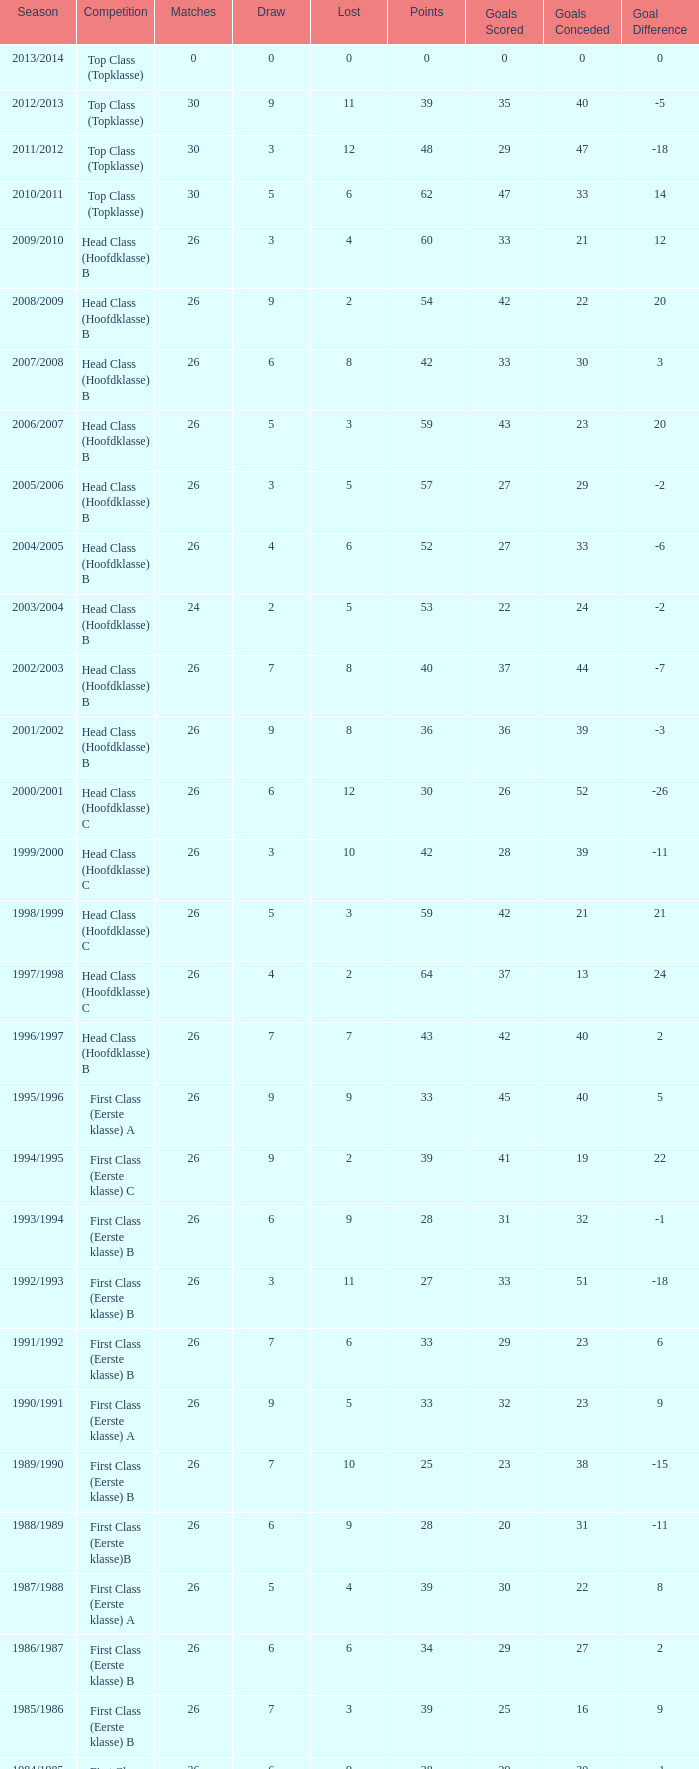Parse the table in full. {'header': ['Season', 'Competition', 'Matches', 'Draw', 'Lost', 'Points', 'Goals Scored', 'Goals Conceded', 'Goal Difference'], 'rows': [['2013/2014', 'Top Class (Topklasse)', '0', '0', '0', '0', '0', '0', '0'], ['2012/2013', 'Top Class (Topklasse)', '30', '9', '11', '39', '35', '40', '-5'], ['2011/2012', 'Top Class (Topklasse)', '30', '3', '12', '48', '29', '47', '-18'], ['2010/2011', 'Top Class (Topklasse)', '30', '5', '6', '62', '47', '33', '14'], ['2009/2010', 'Head Class (Hoofdklasse) B', '26', '3', '4', '60', '33', '21', '12'], ['2008/2009', 'Head Class (Hoofdklasse) B', '26', '9', '2', '54', '42', '22', '20'], ['2007/2008', 'Head Class (Hoofdklasse) B', '26', '6', '8', '42', '33', '30', '3'], ['2006/2007', 'Head Class (Hoofdklasse) B', '26', '5', '3', '59', '43', '23', '20'], ['2005/2006', 'Head Class (Hoofdklasse) B', '26', '3', '5', '57', '27', '29', '-2'], ['2004/2005', 'Head Class (Hoofdklasse) B', '26', '4', '6', '52', '27', '33', '-6'], ['2003/2004', 'Head Class (Hoofdklasse) B', '24', '2', '5', '53', '22', '24', '-2'], ['2002/2003', 'Head Class (Hoofdklasse) B', '26', '7', '8', '40', '37', '44', '-7'], ['2001/2002', 'Head Class (Hoofdklasse) B', '26', '9', '8', '36', '36', '39', '-3'], ['2000/2001', 'Head Class (Hoofdklasse) C', '26', '6', '12', '30', '26', '52', '-26'], ['1999/2000', 'Head Class (Hoofdklasse) C', '26', '3', '10', '42', '28', '39', '-11'], ['1998/1999', 'Head Class (Hoofdklasse) C', '26', '5', '3', '59', '42', '21', '21'], ['1997/1998', 'Head Class (Hoofdklasse) C', '26', '4', '2', '64', '37', '13', '24'], ['1996/1997', 'Head Class (Hoofdklasse) B', '26', '7', '7', '43', '42', '40', '2'], ['1995/1996', 'First Class (Eerste klasse) A', '26', '9', '9', '33', '45', '40', '5'], ['1994/1995', 'First Class (Eerste klasse) C', '26', '9', '2', '39', '41', '19', '22'], ['1993/1994', 'First Class (Eerste klasse) B', '26', '6', '9', '28', '31', '32', '-1'], ['1992/1993', 'First Class (Eerste klasse) B', '26', '3', '11', '27', '33', '51', '-18'], ['1991/1992', 'First Class (Eerste klasse) B', '26', '7', '6', '33', '29', '23', '6'], ['1990/1991', 'First Class (Eerste klasse) A', '26', '9', '5', '33', '32', '23', '9'], ['1989/1990', 'First Class (Eerste klasse) B', '26', '7', '10', '25', '23', '38', '-15'], ['1988/1989', 'First Class (Eerste klasse)B', '26', '6', '9', '28', '20', '31', '-11'], ['1987/1988', 'First Class (Eerste klasse) A', '26', '5', '4', '39', '30', '22', '8'], ['1986/1987', 'First Class (Eerste klasse) B', '26', '6', '6', '34', '29', '27', '2'], ['1985/1986', 'First Class (Eerste klasse) B', '26', '7', '3', '39', '25', '16', '9'], ['1984/1985', 'First Class (Eerste klasse) B', '26', '6', '9', '28', '29', '30', '-1'], ['1983/1984', 'First Class (Eerste klasse) C', '26', '5', '3', '37', '21', '15', '6'], ['1982/1983', 'First Class (Eerste klasse) B', '26', '10', '1', '40', '57', '15', '42'], ['1981/1982', 'First Class (Eerste klasse) B', '26', '8', '3', '38', '43', '28', '15'], ['1980/1981', 'First Class (Eerste klasse) A', '26', '5', '10', '27', '26', '36', '-10'], ['1979/1980', 'First Class (Eerste klasse) B', '26', '6', '9', '28', '24', '37', '-13'], ['1978/1979', 'First Class (Eerste klasse) A', '26', '7', '6', '33', '21', '22', '-1'], ['1977/1978', 'First Class (Eerste klasse) A', '26', '6', '8', '30', '31', '32', '-1'], ['1976/1977', 'First Class (Eerste klasse) B', '26', '7', '3', '39', '37', '27', '10'], ['1975/1976', 'First Class (Eerste klasse)B', '26', '5', '3', '41', '36', '24', '12'], ['1974/1975', 'First Class (Eerste klasse) B', '26', '5', '5', '37', '26', '30', '-4'], ['1973/1974', 'First Class (Eerste klasse)A', '22', '6', '4', '30', '19', '14', '5'], ['1972/1973', 'First Class (Eerste klasse) B', '22', '4', '2', '36', '12', '9', '3'], ['1971/1972', 'First Class (Eerste klasse) B', '20', '3', '4', '29', '14', '14', '0'], ['1970/1971', 'First Class (Eerste klasse) A', '18', '6', '4', '24', '16', '14', '2']]} What is the sum of the losses that a match score larger than 26, a points score of 62, and a draw greater than 5? None. 